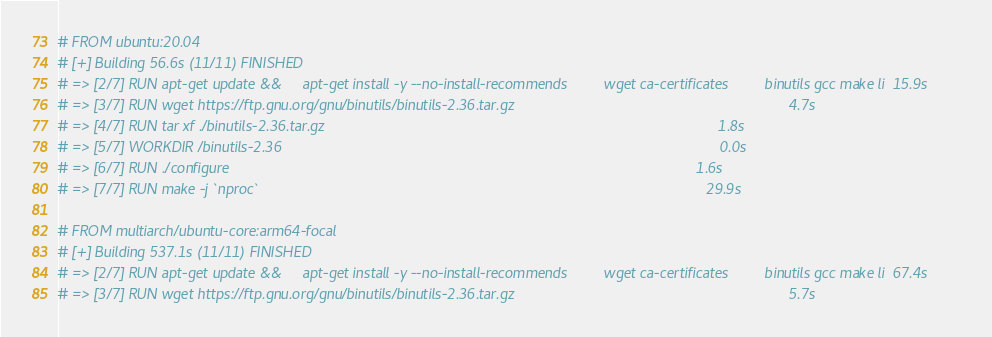Convert code to text. <code><loc_0><loc_0><loc_500><loc_500><_Dockerfile_># FROM ubuntu:20.04
# [+] Building 56.6s (11/11) FINISHED
# => [2/7] RUN apt-get update &&     apt-get install -y --no-install-recommends         wget ca-certificates         binutils gcc make li  15.9s
# => [3/7] RUN wget https://ftp.gnu.org/gnu/binutils/binutils-2.36.tar.gz                                                                   4.7s
# => [4/7] RUN tar xf ./binutils-2.36.tar.gz                                                                                                1.8s
# => [5/7] WORKDIR /binutils-2.36                                                                                                           0.0s
# => [6/7] RUN ./configure                                                                                                                  1.6s
# => [7/7] RUN make -j `nproc`                                                                                                             29.9s

# FROM multiarch/ubuntu-core:arm64-focal
# [+] Building 537.1s (11/11) FINISHED
# => [2/7] RUN apt-get update &&     apt-get install -y --no-install-recommends         wget ca-certificates         binutils gcc make li  67.4s
# => [3/7] RUN wget https://ftp.gnu.org/gnu/binutils/binutils-2.36.tar.gz                                                                   5.7s</code> 